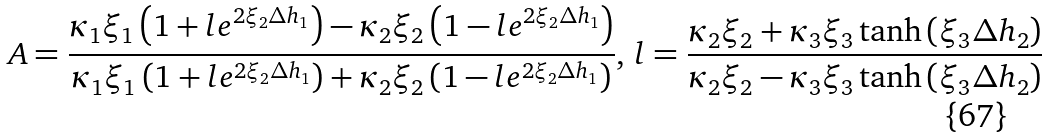Convert formula to latex. <formula><loc_0><loc_0><loc_500><loc_500>A = \frac { \kappa _ { 1 } \xi _ { 1 } \left ( 1 + l e ^ { 2 \xi _ { 2 } \Delta h _ { 1 } } \right ) - \kappa _ { 2 } \xi _ { 2 } \left ( 1 - l e ^ { 2 \xi _ { 2 } \Delta h _ { 1 } } \right ) } { \kappa _ { 1 } \xi _ { 1 } \left ( 1 + l e ^ { 2 \xi _ { 2 } \Delta h _ { 1 } } \right ) + \kappa _ { 2 } \xi _ { 2 } \left ( 1 - l e ^ { 2 \xi _ { 2 } \Delta h _ { 1 } } \right ) } , \, l = \frac { \kappa _ { 2 } \xi _ { 2 } + \kappa _ { 3 } \xi _ { 3 } \tanh { \left ( \xi _ { 3 } \Delta h _ { 2 } \right ) } } { \kappa _ { 2 } \xi _ { 2 } - \kappa _ { 3 } \xi _ { 3 } \tanh { \left ( \xi _ { 3 } \Delta h _ { 2 } \right ) } }</formula> 